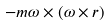Convert formula to latex. <formula><loc_0><loc_0><loc_500><loc_500>- m { \omega } \times ( { \omega } \times { r } )</formula> 